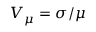Convert formula to latex. <formula><loc_0><loc_0><loc_500><loc_500>V _ { \mu } = \sigma / \mu</formula> 